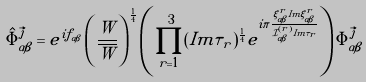<formula> <loc_0><loc_0><loc_500><loc_500>\hat { \Phi } _ { \alpha \beta } ^ { \vec { j } } = e ^ { i f _ { \alpha \beta } } \left ( \frac { W } { \overline { W } } \right ) ^ { \frac { 1 } { 4 } } \left ( \prod _ { r = 1 } ^ { 3 } ( I m \tau _ { r } ) ^ { \frac { 1 } { 4 } } e ^ { i \pi \frac { \xi ^ { r } _ { \alpha \beta } I m \xi ^ { r } _ { \alpha \beta } } { \mathcal { I } ^ { ( r ) } _ { \alpha \beta } I m \tau _ { r } } } \right ) \Phi _ { \alpha \beta } ^ { \vec { j } }</formula> 